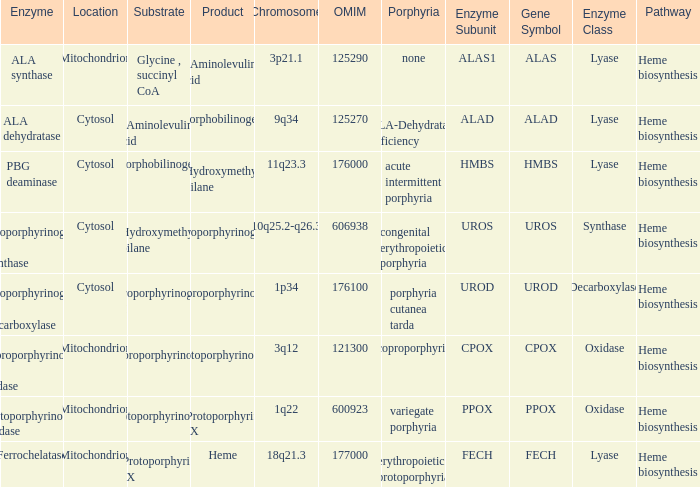What is protoporphyrin ix's substrate? Protoporphyrinogen IX. 